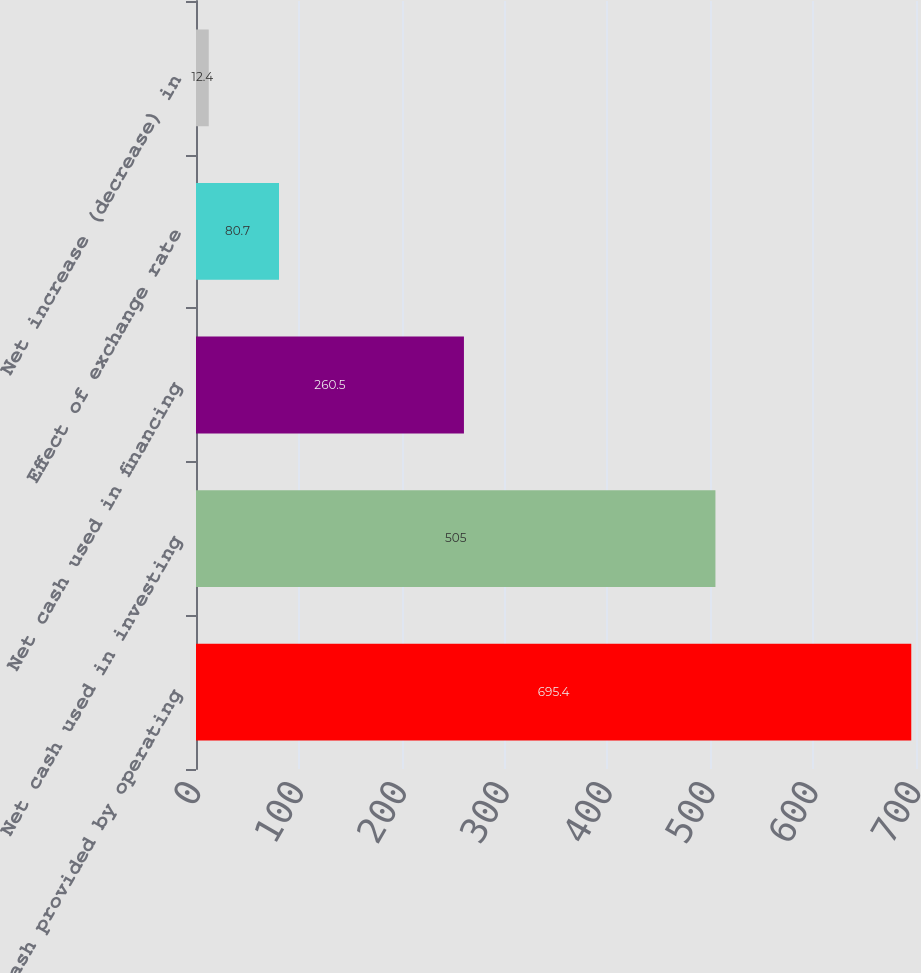<chart> <loc_0><loc_0><loc_500><loc_500><bar_chart><fcel>Net cash provided by operating<fcel>Net cash used in investing<fcel>Net cash used in financing<fcel>Effect of exchange rate<fcel>Net increase (decrease) in<nl><fcel>695.4<fcel>505<fcel>260.5<fcel>80.7<fcel>12.4<nl></chart> 